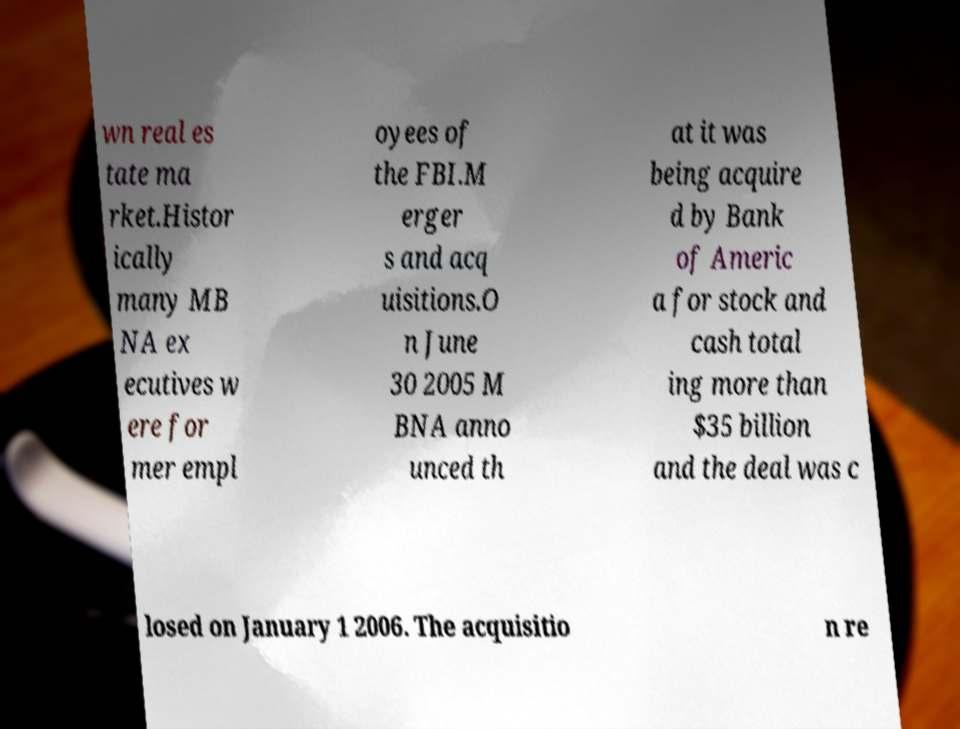Can you read and provide the text displayed in the image?This photo seems to have some interesting text. Can you extract and type it out for me? wn real es tate ma rket.Histor ically many MB NA ex ecutives w ere for mer empl oyees of the FBI.M erger s and acq uisitions.O n June 30 2005 M BNA anno unced th at it was being acquire d by Bank of Americ a for stock and cash total ing more than $35 billion and the deal was c losed on January 1 2006. The acquisitio n re 